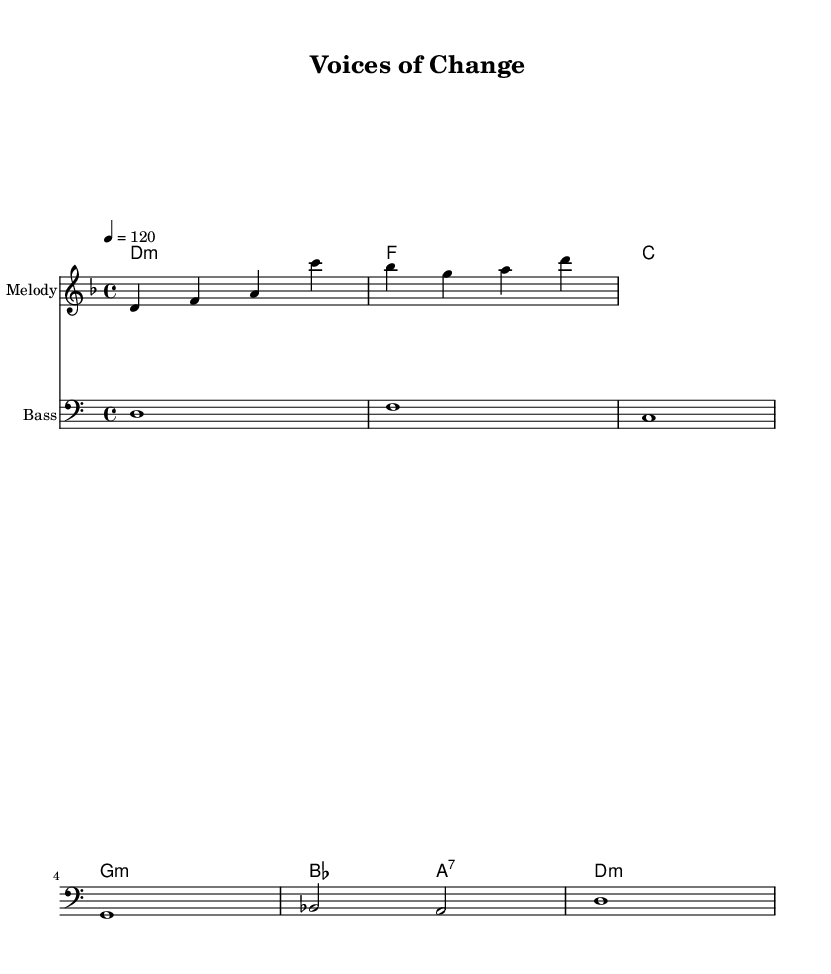What is the key signature of this music? The key signature indicated in the score is D minor, which typically contains one flat (B flat). This is evident from the global section where the key is explicitly stated.
Answer: D minor What is the time signature of the piece? The time signature shown in the score is 4/4, meaning there are four beats in each measure and the quarter note receives one beat. This is also noted in the global section of the code.
Answer: 4/4 What is the tempo marking in this piece? The tempo marking is set to 120 beats per minute (BPM), which indicates a moderately fast pace. This is found in the global section where it specifies "4 = 120".
Answer: 120 How many measures are in the melody? The melody consists of a total of 4 measures as indicated by the four sets of note sequences before the vertical bar indicating the end of each measure.
Answer: 4 What is the first chord in the harmonic progression? The first chord in the harmonic progression is D minor, noted at the beginning of the chord mode in the score. This is seen before the first vertical bar in the harmonic section.
Answer: D minor What are the lyrics associated with the chorus? The chorus lyrics provided in the score express empowerment and a call for rights and freedom, specified in the chorusWords section. The lyrics begin with "Hear our voices, feel our strength".
Answer: Hear our voices, feel our strength, Rights and freedom, we demand What is the instrument name for the melody staff? The instrument name for the melody staff is indicated as "Melody" in the score, which identifies the type of musical line represented in that staff.
Answer: Melody 